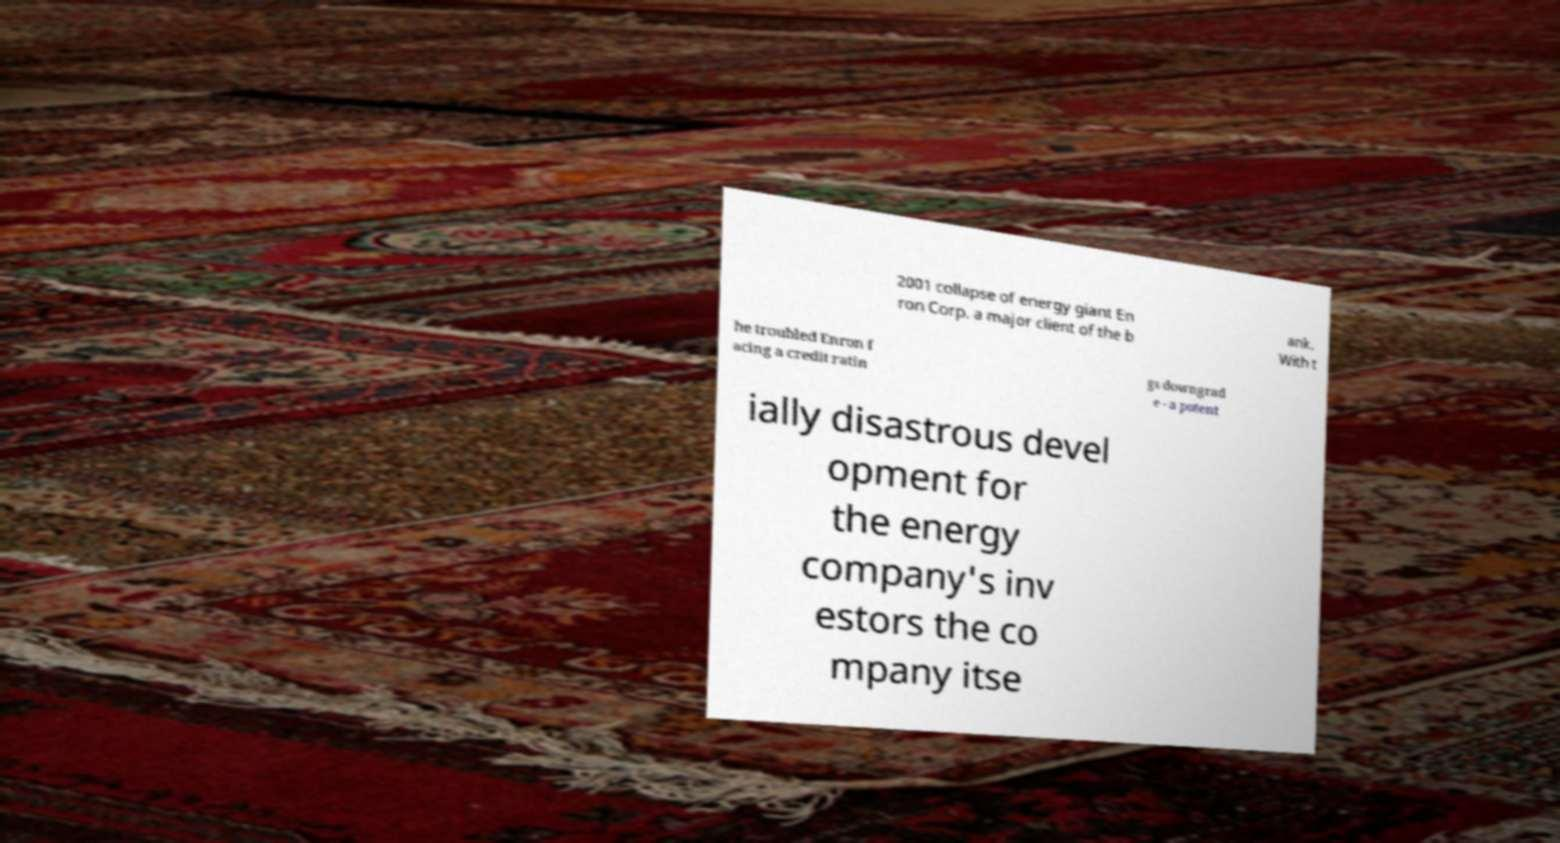Can you accurately transcribe the text from the provided image for me? 2001 collapse of energy giant En ron Corp. a major client of the b ank. With t he troubled Enron f acing a credit ratin gs downgrad e - a potent ially disastrous devel opment for the energy company's inv estors the co mpany itse 